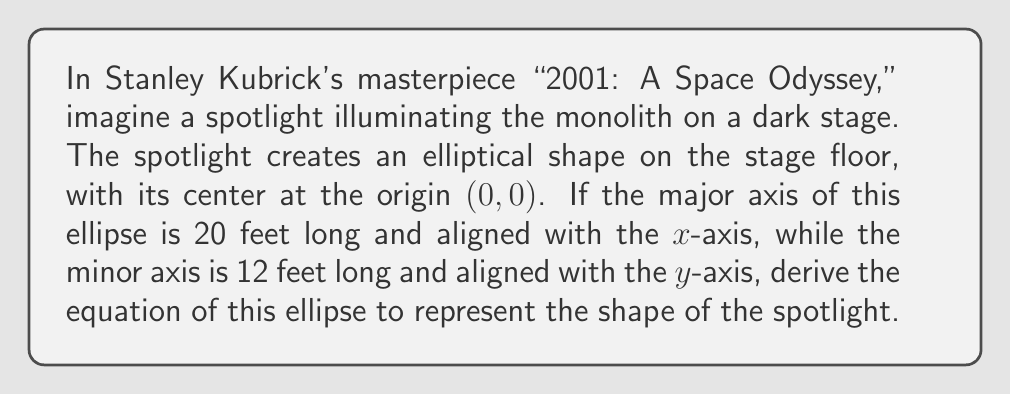Solve this math problem. Let's approach this step-by-step:

1) The general equation of an ellipse with its center at the origin is:

   $$\frac{x^2}{a^2} + \frac{y^2}{b^2} = 1$$

   where $a$ is the length of the semi-major axis and $b$ is the length of the semi-minor axis.

2) In this case, we're given the full length of the axes:
   - Major axis = 20 feet, so $a = 10$ feet
   - Minor axis = 12 feet, so $b = 6$ feet

3) Substituting these values into our general equation:

   $$\frac{x^2}{10^2} + \frac{y^2}{6^2} = 1$$

4) Simplify:

   $$\frac{x^2}{100} + \frac{y^2}{36} = 1$$

5) To get rid of fractions, multiply both sides by 3600 (the LCM of 100 and 36):

   $$36x^2 + 100y^2 = 3600$$

This final equation represents the elliptical shape of the spotlight on the stage floor, reminiscent of the way Kubrick might have illuminated the mysterious monolith in his groundbreaking film.
Answer: $$36x^2 + 100y^2 = 3600$$ 